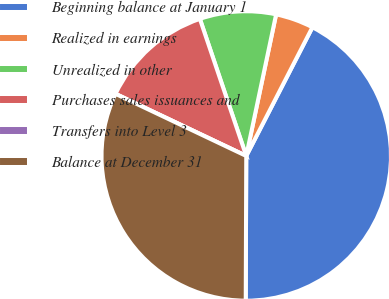Convert chart. <chart><loc_0><loc_0><loc_500><loc_500><pie_chart><fcel>Beginning balance at January 1<fcel>Realized in earnings<fcel>Unrealized in other<fcel>Purchases sales issuances and<fcel>Transfers into Level 3<fcel>Balance at December 31<nl><fcel>42.5%<fcel>4.25%<fcel>8.5%<fcel>12.75%<fcel>0.0%<fcel>32.0%<nl></chart> 